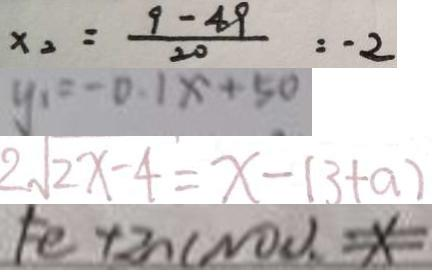<formula> <loc_0><loc_0><loc_500><loc_500>x _ { 2 } = \frac { 9 - 4 9 } { 2 0 } = - 2 
 y _ { 1 } = - 0 . 1 x + 5 0 
 2 \sqrt { 2 x - 4 } = x - ( 3 + a ) 
 F e + 2 n ( N O ) . x</formula> 